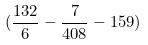<formula> <loc_0><loc_0><loc_500><loc_500>( \frac { 1 3 2 } { 6 } - \frac { 7 } { 4 0 8 } - 1 5 9 )</formula> 